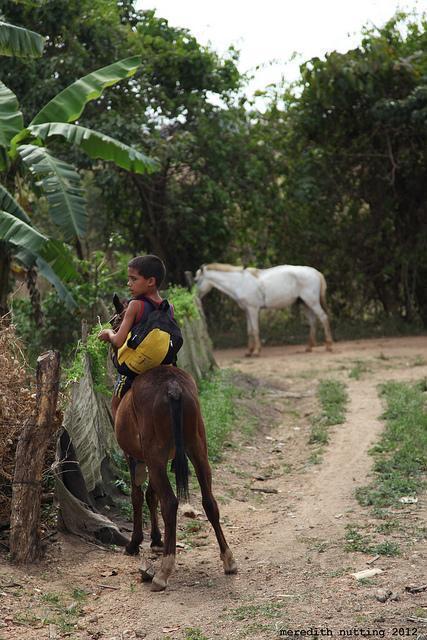How many horses can be seen?
Give a very brief answer. 2. 